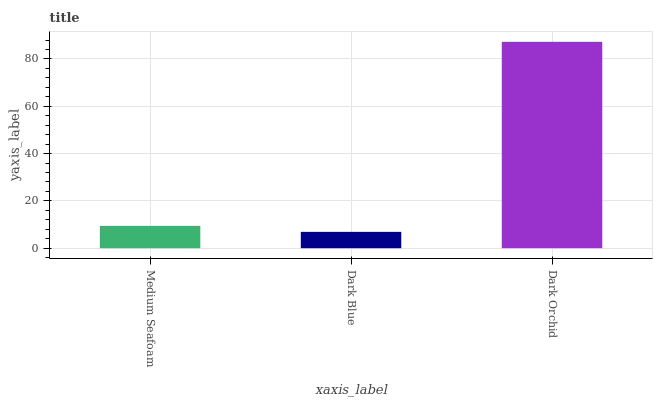Is Dark Blue the minimum?
Answer yes or no. Yes. Is Dark Orchid the maximum?
Answer yes or no. Yes. Is Dark Orchid the minimum?
Answer yes or no. No. Is Dark Blue the maximum?
Answer yes or no. No. Is Dark Orchid greater than Dark Blue?
Answer yes or no. Yes. Is Dark Blue less than Dark Orchid?
Answer yes or no. Yes. Is Dark Blue greater than Dark Orchid?
Answer yes or no. No. Is Dark Orchid less than Dark Blue?
Answer yes or no. No. Is Medium Seafoam the high median?
Answer yes or no. Yes. Is Medium Seafoam the low median?
Answer yes or no. Yes. Is Dark Blue the high median?
Answer yes or no. No. Is Dark Orchid the low median?
Answer yes or no. No. 